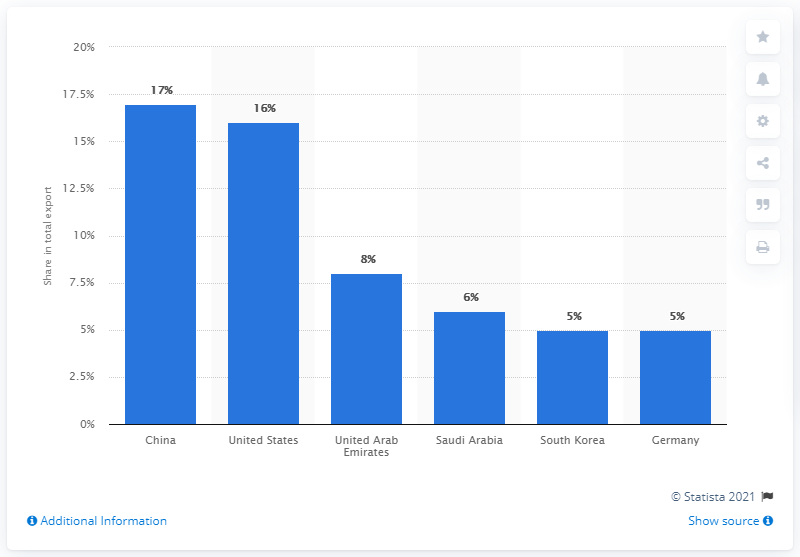Outline some significant characteristics in this image. In 2019, Ethiopia's most important export partner was China. 